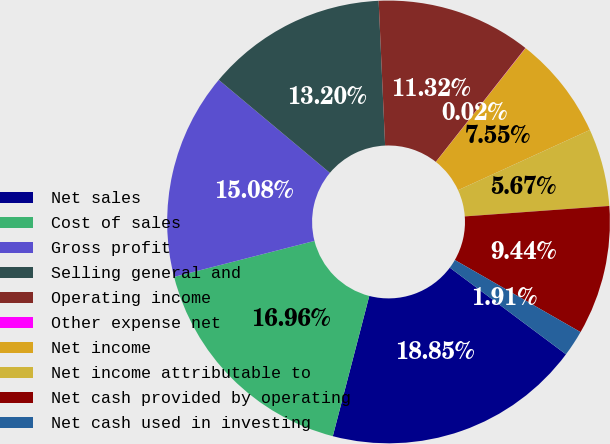<chart> <loc_0><loc_0><loc_500><loc_500><pie_chart><fcel>Net sales<fcel>Cost of sales<fcel>Gross profit<fcel>Selling general and<fcel>Operating income<fcel>Other expense net<fcel>Net income<fcel>Net income attributable to<fcel>Net cash provided by operating<fcel>Net cash used in investing<nl><fcel>18.85%<fcel>16.96%<fcel>15.08%<fcel>13.2%<fcel>11.32%<fcel>0.02%<fcel>7.55%<fcel>5.67%<fcel>9.44%<fcel>1.91%<nl></chart> 